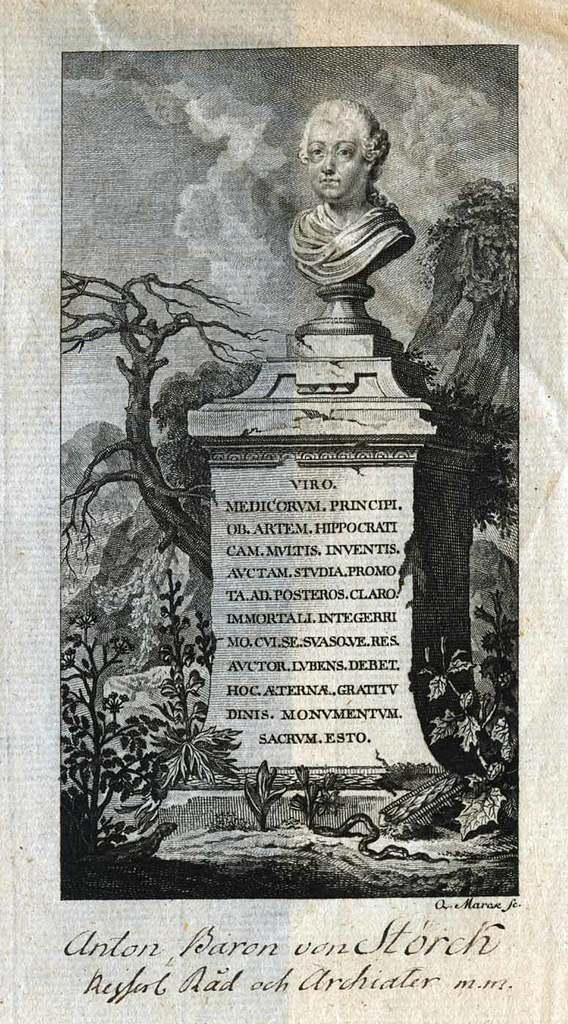How would you summarize this image in a sentence or two? In this image we can see a poster. On poster we can see a statue and a memorial wall. There is some text at the bottom of the poster. There are many trees and plants in the image. There are few hills in the image. There is the cloudy sky in the image. 